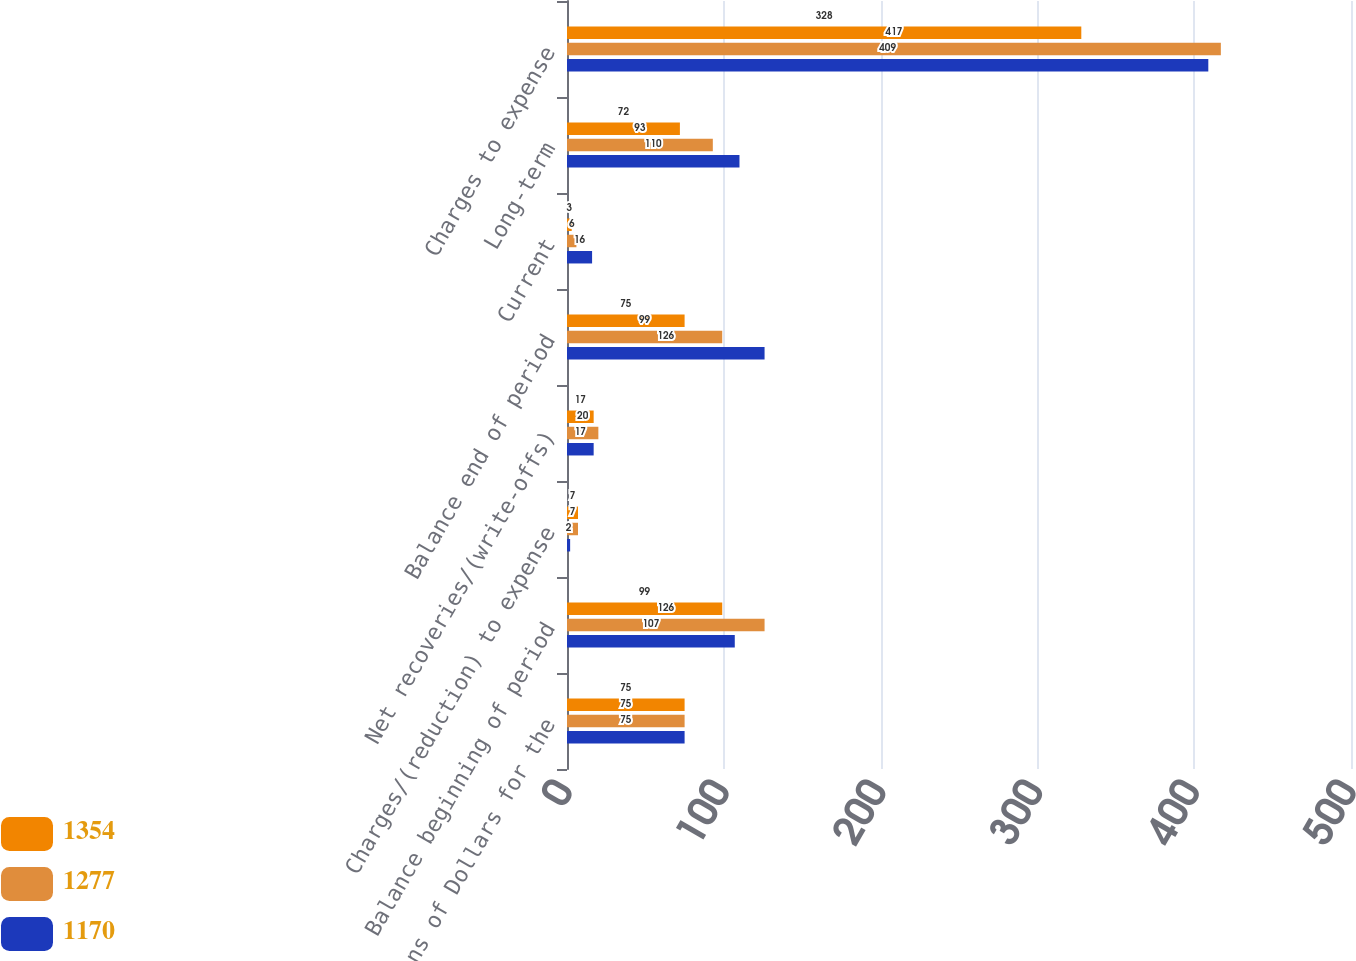<chart> <loc_0><loc_0><loc_500><loc_500><stacked_bar_chart><ecel><fcel>Millions of Dollars for the<fcel>Balance beginning of period<fcel>Charges/(reduction) to expense<fcel>Net recoveries/(write-offs)<fcel>Balance end of period<fcel>Current<fcel>Long-term<fcel>Charges to expense<nl><fcel>1354<fcel>75<fcel>99<fcel>7<fcel>17<fcel>75<fcel>3<fcel>72<fcel>328<nl><fcel>1277<fcel>75<fcel>126<fcel>7<fcel>20<fcel>99<fcel>6<fcel>93<fcel>417<nl><fcel>1170<fcel>75<fcel>107<fcel>2<fcel>17<fcel>126<fcel>16<fcel>110<fcel>409<nl></chart> 